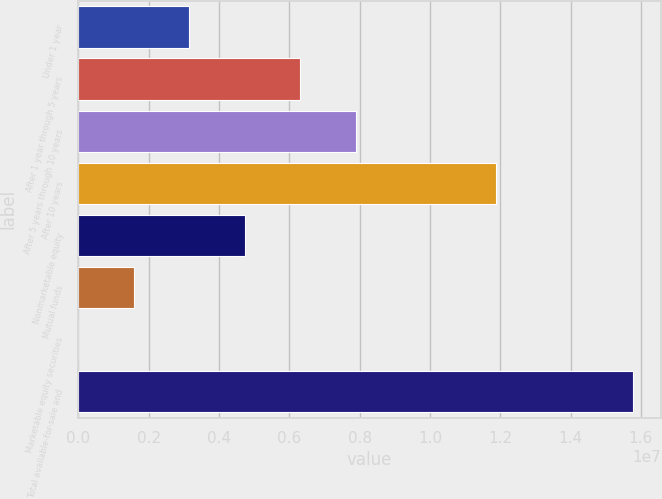Convert chart. <chart><loc_0><loc_0><loc_500><loc_500><bar_chart><fcel>Under 1 year<fcel>After 1 year through 5 years<fcel>After 5 years through 10 years<fcel>After 10 years<fcel>Nonmarketable equity<fcel>Mutual funds<fcel>Marketable equity securities<fcel>Total available-for-sale and<nl><fcel>3.15606e+06<fcel>6.31126e+06<fcel>7.88886e+06<fcel>1.18848e+07<fcel>4.73366e+06<fcel>1.57846e+06<fcel>861<fcel>1.57769e+07<nl></chart> 